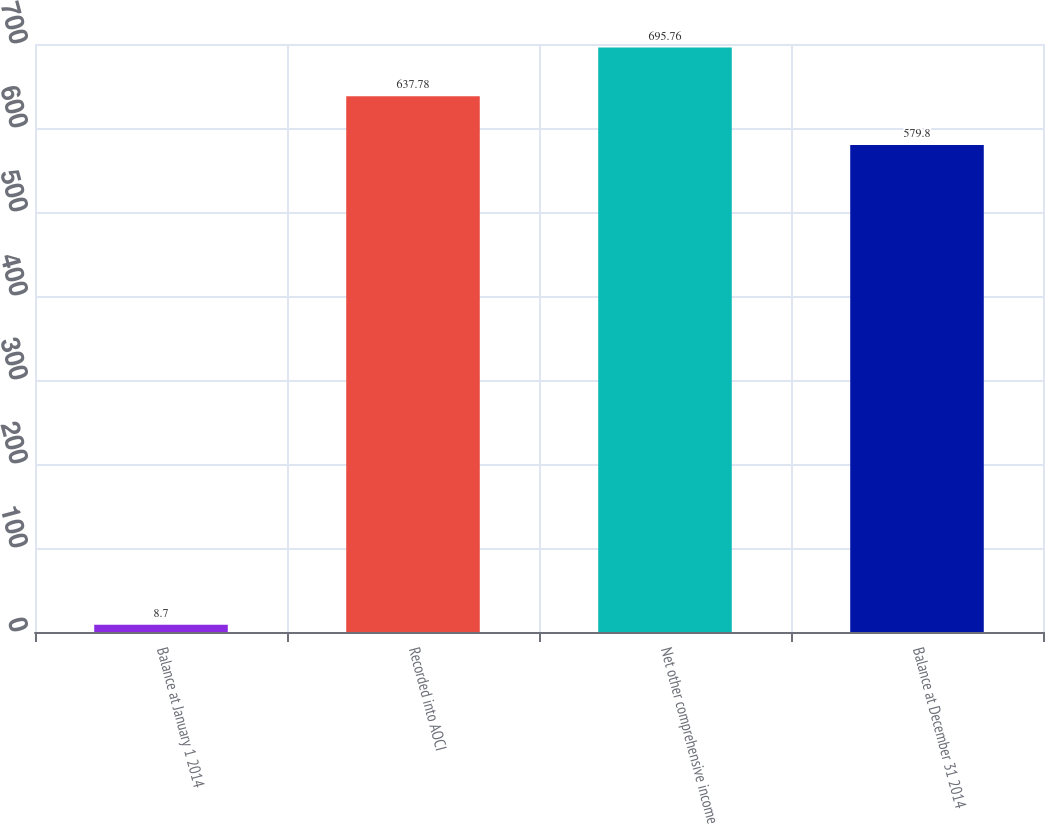Convert chart to OTSL. <chart><loc_0><loc_0><loc_500><loc_500><bar_chart><fcel>Balance at January 1 2014<fcel>Recorded into AOCI<fcel>Net other comprehensive income<fcel>Balance at December 31 2014<nl><fcel>8.7<fcel>637.78<fcel>695.76<fcel>579.8<nl></chart> 